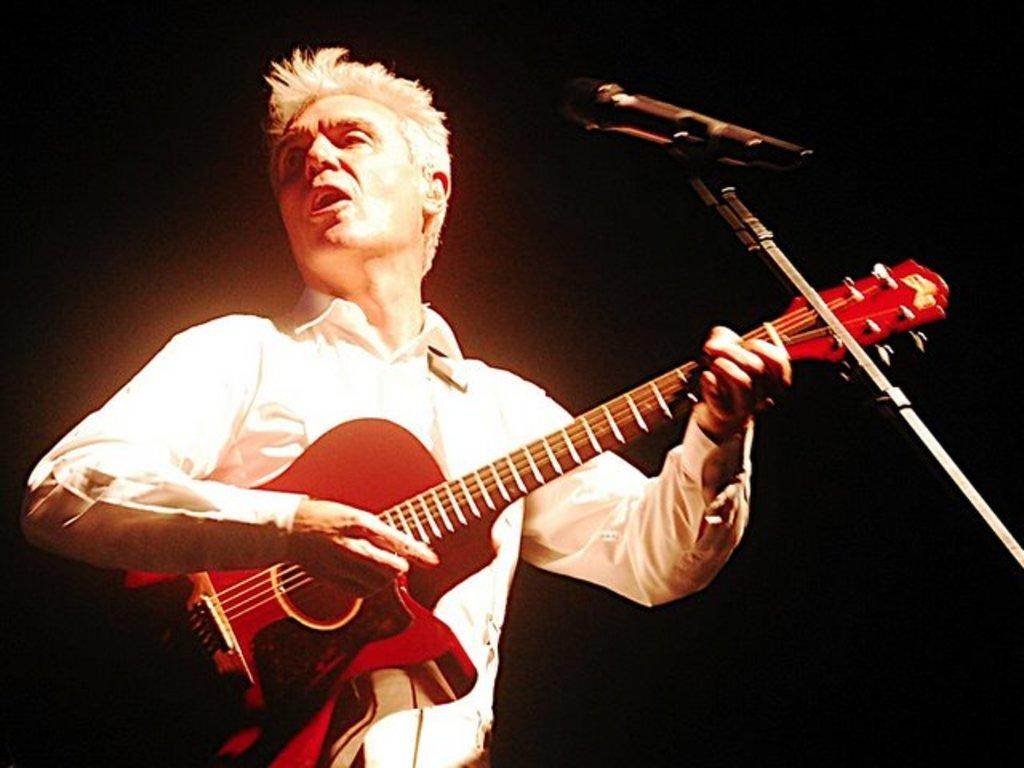What is the main subject of the image? There is a person in the image. What is the person holding in the image? The person is holding a guitar. What object is in front of the person? There is a microphone in front of the person. What type of pollution can be seen in the image? There is no pollution visible in the image; it features a person holding a guitar with a microphone in front of them. Is there a throne present in the image? No, there is no throne present in the image. 